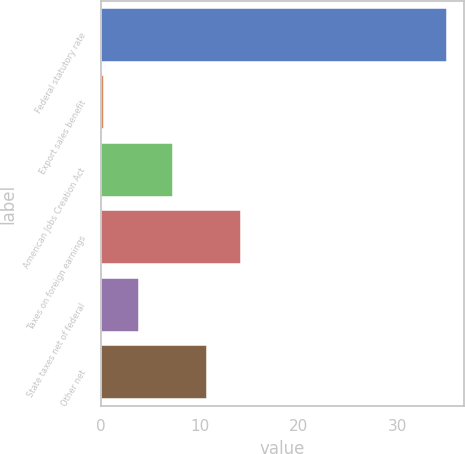Convert chart to OTSL. <chart><loc_0><loc_0><loc_500><loc_500><bar_chart><fcel>Federal statutory rate<fcel>Export sales benefit<fcel>American Jobs Creation Act<fcel>Taxes on foreign earnings<fcel>State taxes net of federal<fcel>Other net<nl><fcel>35<fcel>0.35<fcel>7.28<fcel>14.21<fcel>3.81<fcel>10.75<nl></chart> 